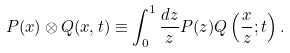Convert formula to latex. <formula><loc_0><loc_0><loc_500><loc_500>P ( x ) \otimes Q ( x , t ) \equiv \int _ { 0 } ^ { 1 } { \frac { d z } { z } } P ( z ) Q \left ( { \frac { x } { z } } ; t \right ) .</formula> 